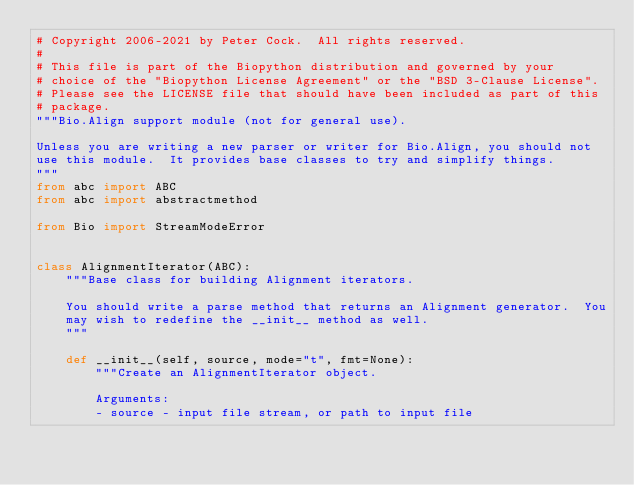<code> <loc_0><loc_0><loc_500><loc_500><_Python_># Copyright 2006-2021 by Peter Cock.  All rights reserved.
#
# This file is part of the Biopython distribution and governed by your
# choice of the "Biopython License Agreement" or the "BSD 3-Clause License".
# Please see the LICENSE file that should have been included as part of this
# package.
"""Bio.Align support module (not for general use).

Unless you are writing a new parser or writer for Bio.Align, you should not
use this module.  It provides base classes to try and simplify things.
"""
from abc import ABC
from abc import abstractmethod

from Bio import StreamModeError


class AlignmentIterator(ABC):
    """Base class for building Alignment iterators.

    You should write a parse method that returns an Alignment generator.  You
    may wish to redefine the __init__ method as well.
    """

    def __init__(self, source, mode="t", fmt=None):
        """Create an AlignmentIterator object.

        Arguments:
        - source - input file stream, or path to input file
</code> 